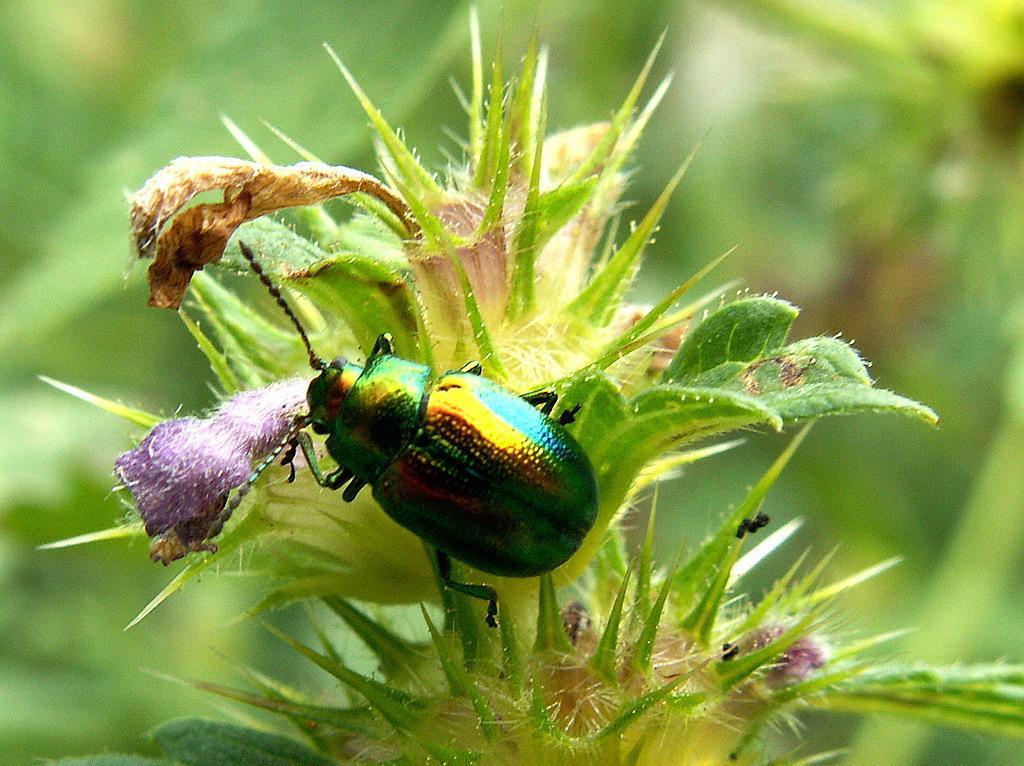Describe this image in one or two sentences. In the front of the image there is a plant and an insect. In the background of the image it is blurry. 